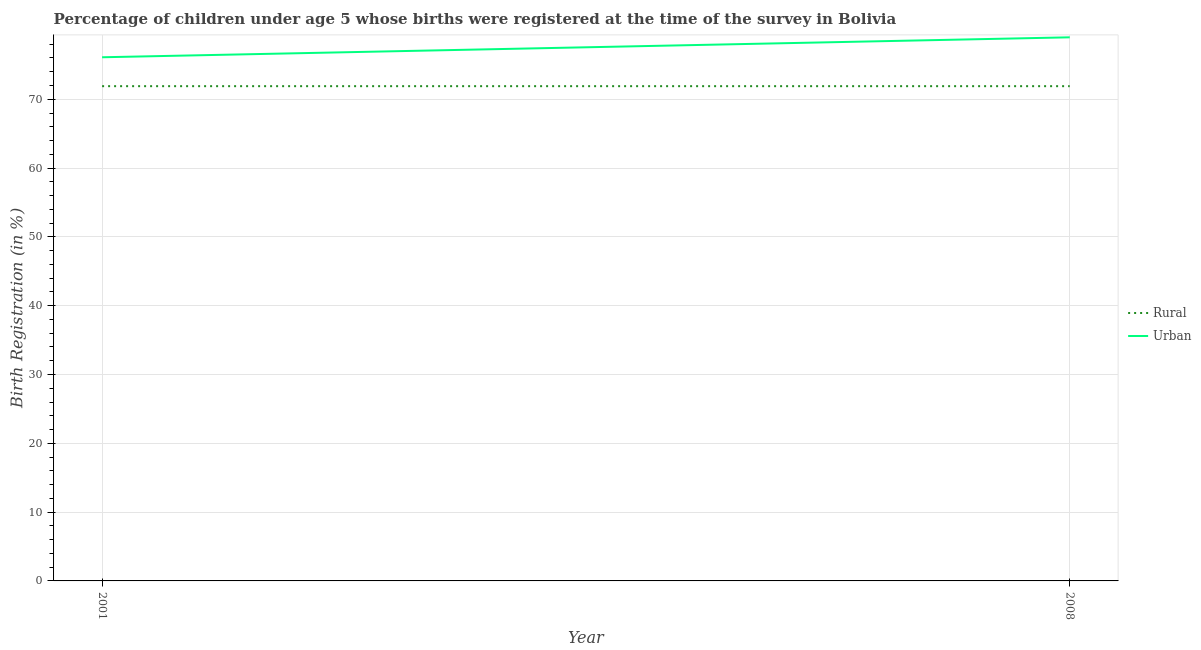How many different coloured lines are there?
Provide a short and direct response. 2. Is the number of lines equal to the number of legend labels?
Offer a very short reply. Yes. What is the rural birth registration in 2008?
Your answer should be very brief. 71.9. Across all years, what is the maximum urban birth registration?
Provide a short and direct response. 79. Across all years, what is the minimum urban birth registration?
Make the answer very short. 76.1. In which year was the urban birth registration maximum?
Your answer should be compact. 2008. In which year was the urban birth registration minimum?
Make the answer very short. 2001. What is the total urban birth registration in the graph?
Make the answer very short. 155.1. What is the difference between the rural birth registration in 2001 and that in 2008?
Keep it short and to the point. 0. What is the difference between the urban birth registration in 2008 and the rural birth registration in 2001?
Your response must be concise. 7.1. What is the average urban birth registration per year?
Keep it short and to the point. 77.55. In the year 2001, what is the difference between the urban birth registration and rural birth registration?
Offer a very short reply. 4.2. In how many years, is the urban birth registration greater than 8 %?
Offer a very short reply. 2. What is the ratio of the urban birth registration in 2001 to that in 2008?
Make the answer very short. 0.96. Is the urban birth registration in 2001 less than that in 2008?
Give a very brief answer. Yes. How many lines are there?
Keep it short and to the point. 2. What is the difference between two consecutive major ticks on the Y-axis?
Keep it short and to the point. 10. Are the values on the major ticks of Y-axis written in scientific E-notation?
Your answer should be compact. No. Does the graph contain grids?
Offer a terse response. Yes. Where does the legend appear in the graph?
Your response must be concise. Center right. What is the title of the graph?
Give a very brief answer. Percentage of children under age 5 whose births were registered at the time of the survey in Bolivia. What is the label or title of the X-axis?
Offer a terse response. Year. What is the label or title of the Y-axis?
Offer a terse response. Birth Registration (in %). What is the Birth Registration (in %) in Rural in 2001?
Keep it short and to the point. 71.9. What is the Birth Registration (in %) of Urban in 2001?
Your response must be concise. 76.1. What is the Birth Registration (in %) in Rural in 2008?
Your answer should be very brief. 71.9. What is the Birth Registration (in %) in Urban in 2008?
Keep it short and to the point. 79. Across all years, what is the maximum Birth Registration (in %) of Rural?
Make the answer very short. 71.9. Across all years, what is the maximum Birth Registration (in %) of Urban?
Offer a very short reply. 79. Across all years, what is the minimum Birth Registration (in %) in Rural?
Keep it short and to the point. 71.9. Across all years, what is the minimum Birth Registration (in %) of Urban?
Make the answer very short. 76.1. What is the total Birth Registration (in %) in Rural in the graph?
Offer a very short reply. 143.8. What is the total Birth Registration (in %) of Urban in the graph?
Your response must be concise. 155.1. What is the difference between the Birth Registration (in %) of Rural in 2001 and the Birth Registration (in %) of Urban in 2008?
Provide a succinct answer. -7.1. What is the average Birth Registration (in %) of Rural per year?
Make the answer very short. 71.9. What is the average Birth Registration (in %) of Urban per year?
Give a very brief answer. 77.55. What is the ratio of the Birth Registration (in %) of Urban in 2001 to that in 2008?
Offer a terse response. 0.96. What is the difference between the highest and the second highest Birth Registration (in %) in Rural?
Give a very brief answer. 0. What is the difference between the highest and the second highest Birth Registration (in %) in Urban?
Offer a terse response. 2.9. What is the difference between the highest and the lowest Birth Registration (in %) of Urban?
Your response must be concise. 2.9. 